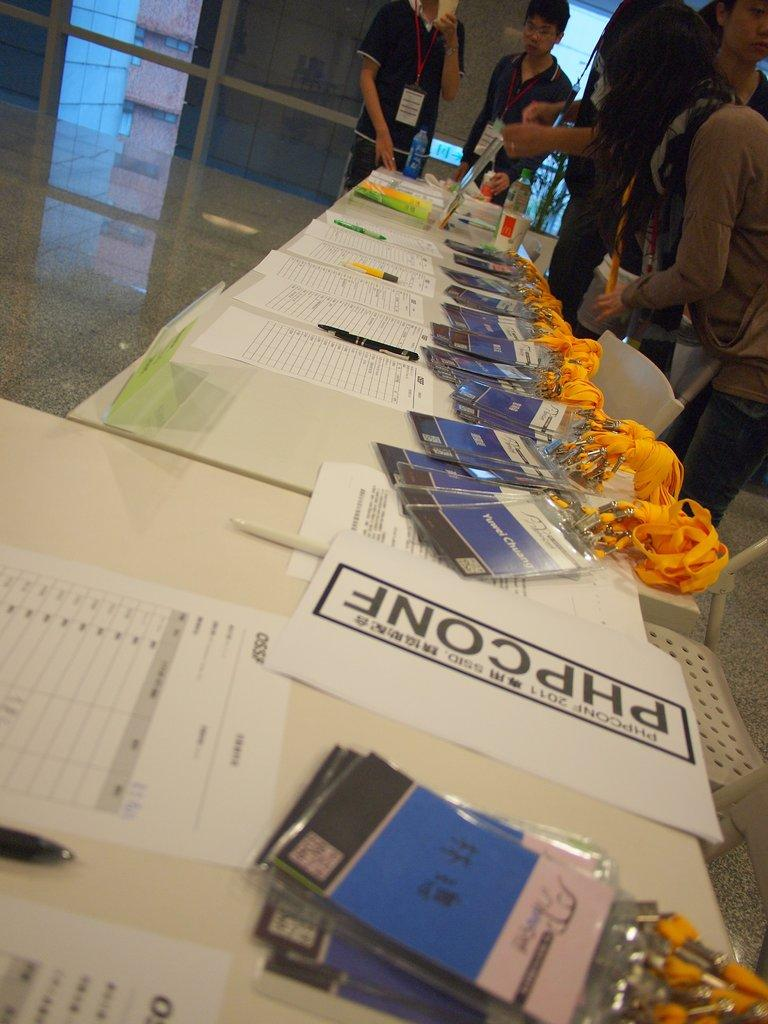What type of objects can be seen on the table in the image? There are papers, pens, and ID cards with tags on the table in the image. What might be used for writing on the papers in the image? The pens in the image might be used for writing on the papers. What type of identification is depicted on the ID cards in the image? The ID cards in the image have tags attached to them. What type of furniture is present in the image? There are chairs in the image. Are there any people in the image? Yes, there are people standing in the image. What type of quartz can be seen on the table in the image? There is no quartz present in the image. How does the balloon contribute to the people's identification in the image? There is no balloon present in the image, and therefore it does not contribute to the people's identification. 